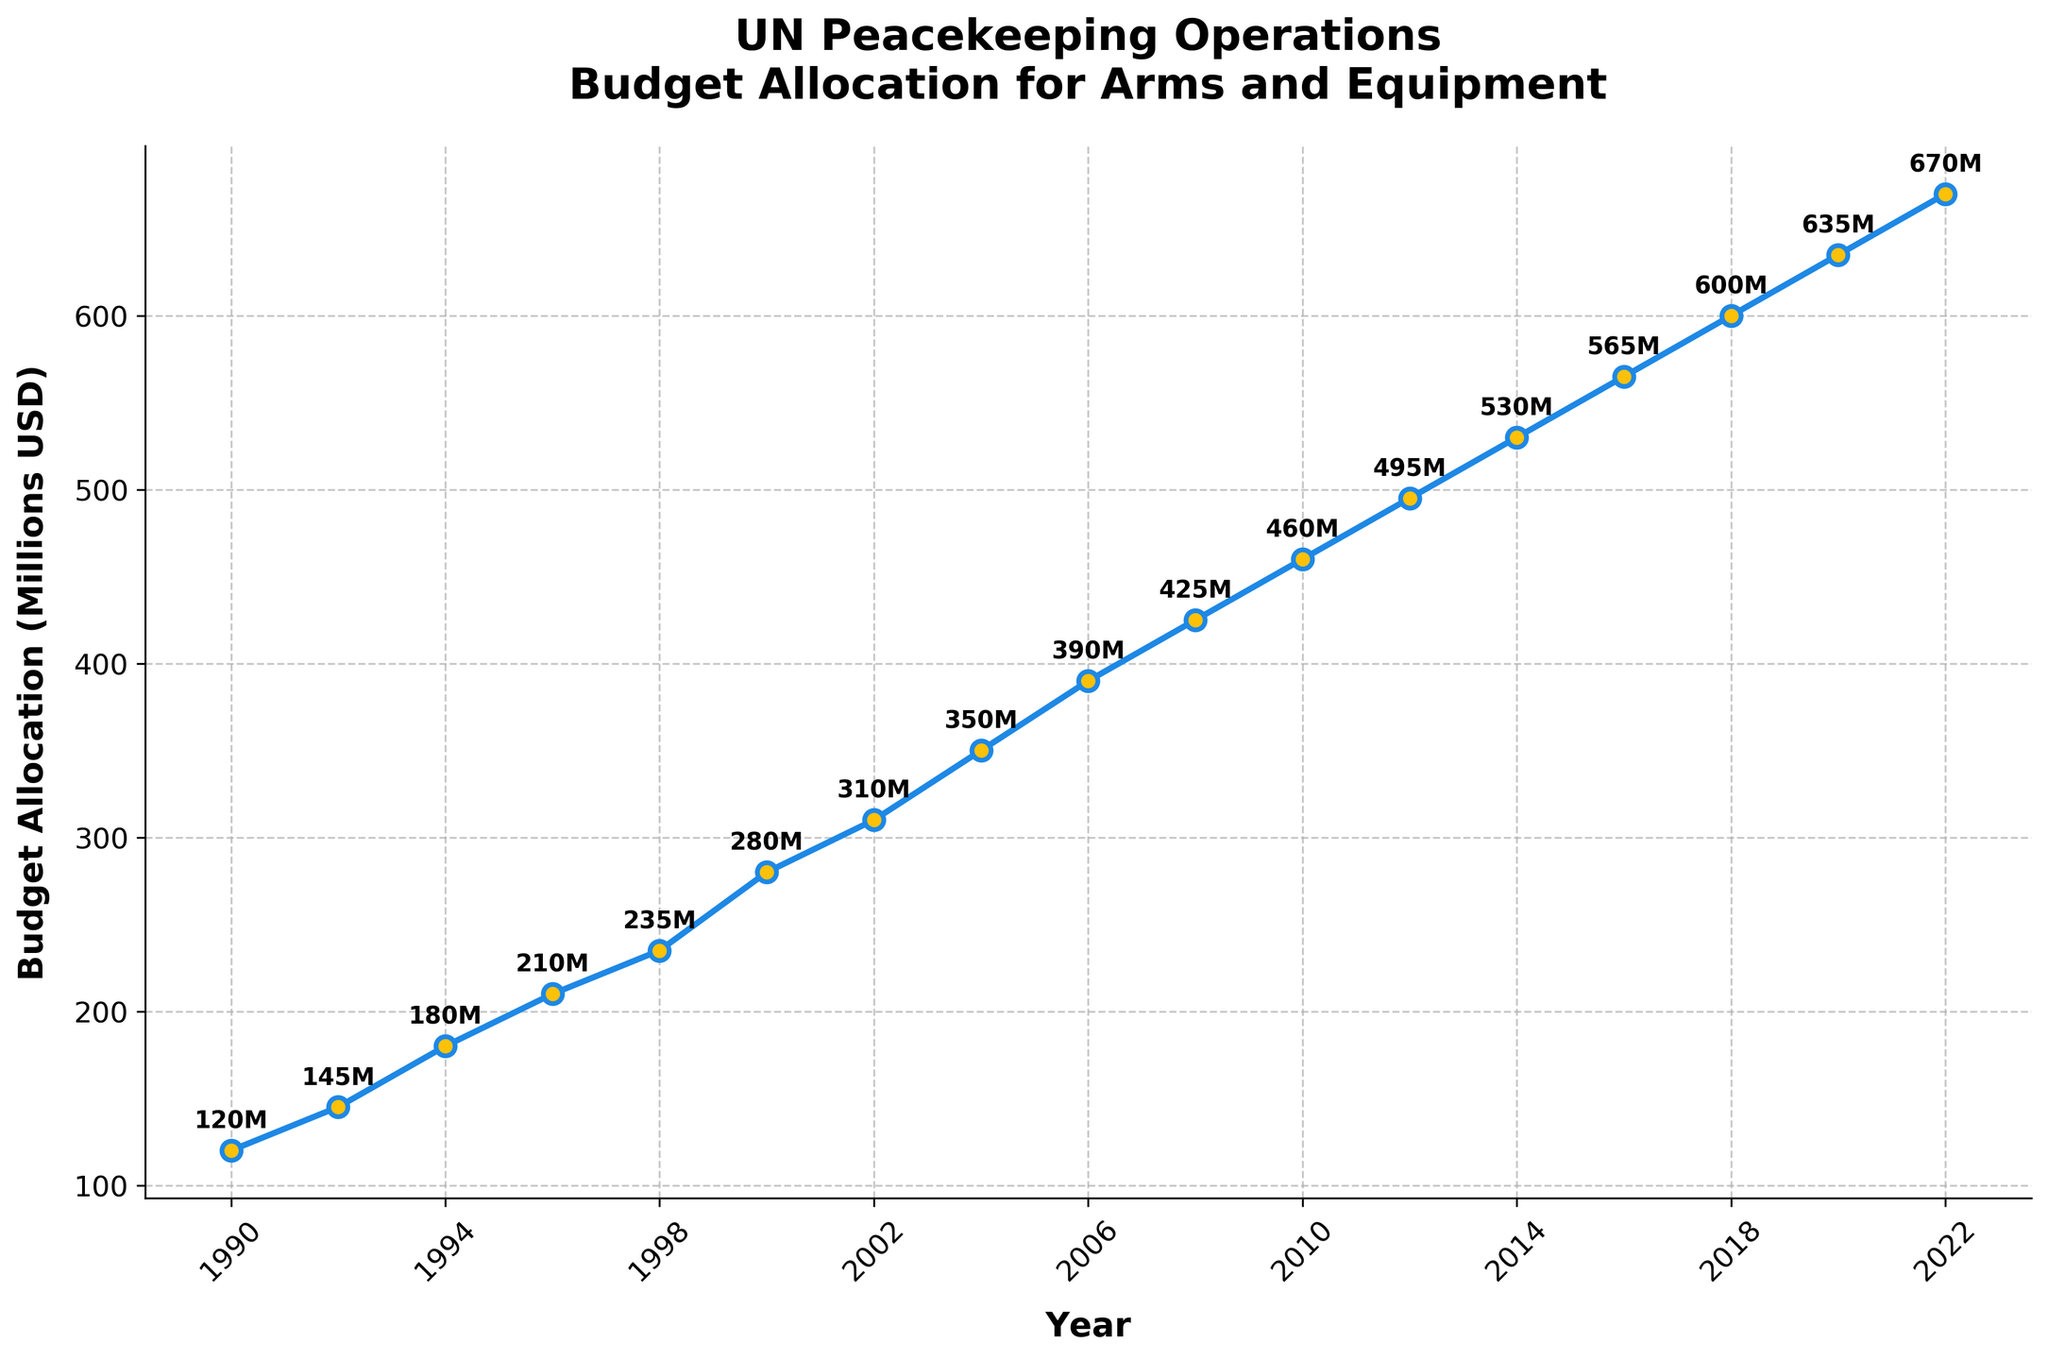What is the trend in budget allocation for arms and equipment from 1990 to 2022? The trend in the budget allocation has been consistently increasing from 1990 (120 million USD) to 2022 (670 million USD), indicating a steady rise over the years.
Answer: Increasing Which year had the highest budget allocation for arms and equipment? By observing the highest point on the graph, the year with the highest budget allocation is 2022 with 670 million USD.
Answer: 2022 Compare the budget allocations for arms and equipment in 2000 and in 2020. Which year had a higher budget? In 2000, the budget allocation was 280 million USD, whereas in 2020, it was 635 million USD. By comparing these two values, 2020 had a higher budget allocation.
Answer: 2020 How much did the budget allocation increase from 2010 to 2022? The budget allocation in 2010 was 460 million USD and in 2022, it was 670 million USD. The increase is calculated as 670 - 460 = 210 million USD.
Answer: 210 million USD What is the average budget allocation for arms and equipment from 1990 to 2000? The budget figures for the years 1990, 1992, 1994, 1996, 1998, and 2000 are 120, 145, 180, 210, 235, and 280 million USD, respectively. The average is calculated as (120 + 145 + 180 + 210 + 235 + 280) / 6 = 195 million USD.
Answer: 195 million USD In which year did the budget allocation surpass 400 million USD for the first time? By examining the graph, the first year the budget allocation surpassed 400 million USD was 2008 with 425 million USD.
Answer: 2008 What is the total budget allocation for arms and equipment from 1990 to 2022? Summing up all the budget allocations from each year: 120 + 145 + 180 + 210 + 235 + 280 + 310 + 350 + 390 + 425 + 460 + 495 + 530 + 565 + 600 + 635 + 670 = 7490 million USD.
Answer: 7490 million USD Which two years had the smallest increase in budget allocation compared to their preceding years? The smallest increases can be observed between 1992 to 1994 (145 to 180 million USD) which is an increase of 35 million USD, and 2020 to 2022 (635 to 670 million USD) which is also an increase of 35 million USD.
Answer: 1992 to 1994 and 2020 to 2022 What is the average annual increase in budget allocation from 1990 to 2022? The total increase from 1990 to 2022 is 670 - 120 = 550 million USD. There are 16 intervals (2022-1990 = 32 years, thus 32-1=31 years), so the average annual increase is 550 / 32 ≈ 17.19 million USD/year.
Answer: 17.19 million USD/year 